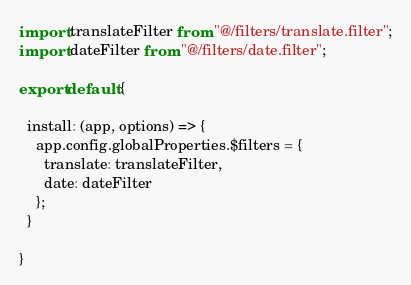<code> <loc_0><loc_0><loc_500><loc_500><_JavaScript_>import translateFilter from "@/filters/translate.filter";
import dateFilter from "@/filters/date.filter";

export default {

  install: (app, options) => {
    app.config.globalProperties.$filters = {
      translate: translateFilter,
      date: dateFilter
    };
  }

}</code> 